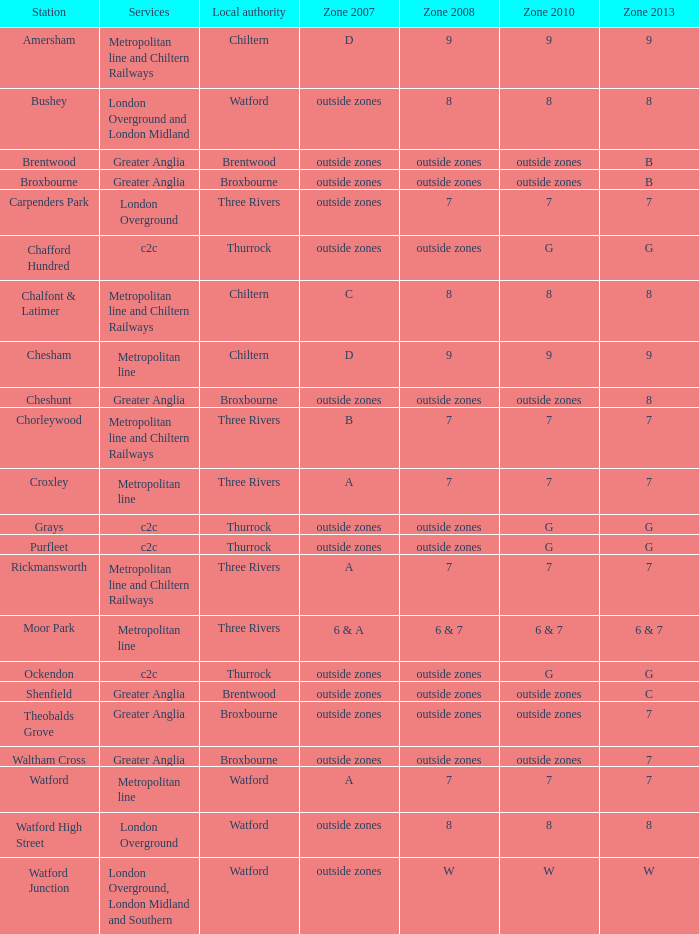Which Zone 2008 has Services of greater anglia, and a Station of cheshunt? Outside zones. 